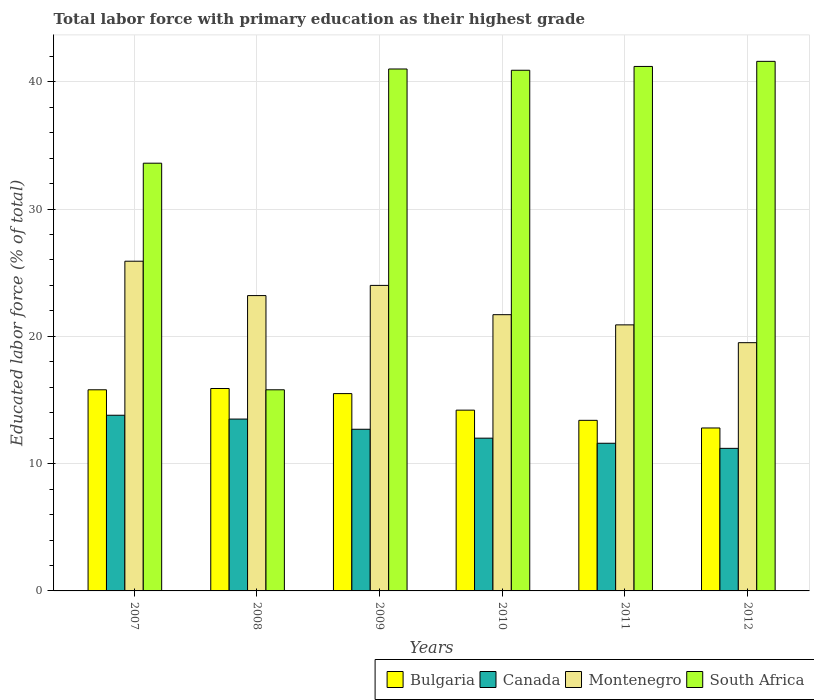How many groups of bars are there?
Give a very brief answer. 6. How many bars are there on the 3rd tick from the left?
Ensure brevity in your answer.  4. What is the label of the 2nd group of bars from the left?
Provide a short and direct response. 2008. What is the percentage of total labor force with primary education in Bulgaria in 2012?
Make the answer very short. 12.8. Across all years, what is the maximum percentage of total labor force with primary education in Montenegro?
Make the answer very short. 25.9. Across all years, what is the minimum percentage of total labor force with primary education in Bulgaria?
Offer a terse response. 12.8. In which year was the percentage of total labor force with primary education in Bulgaria minimum?
Your answer should be compact. 2012. What is the total percentage of total labor force with primary education in Montenegro in the graph?
Give a very brief answer. 135.2. What is the difference between the percentage of total labor force with primary education in Canada in 2008 and that in 2009?
Your answer should be compact. 0.8. What is the difference between the percentage of total labor force with primary education in Montenegro in 2011 and the percentage of total labor force with primary education in Canada in 2007?
Offer a very short reply. 7.1. What is the average percentage of total labor force with primary education in Canada per year?
Ensure brevity in your answer.  12.47. In the year 2007, what is the difference between the percentage of total labor force with primary education in Canada and percentage of total labor force with primary education in South Africa?
Your answer should be compact. -19.8. What is the ratio of the percentage of total labor force with primary education in Montenegro in 2008 to that in 2012?
Your answer should be compact. 1.19. Is the percentage of total labor force with primary education in Montenegro in 2011 less than that in 2012?
Your response must be concise. No. What is the difference between the highest and the second highest percentage of total labor force with primary education in Canada?
Make the answer very short. 0.3. What is the difference between the highest and the lowest percentage of total labor force with primary education in Montenegro?
Provide a short and direct response. 6.4. Is it the case that in every year, the sum of the percentage of total labor force with primary education in Canada and percentage of total labor force with primary education in Montenegro is greater than the sum of percentage of total labor force with primary education in Bulgaria and percentage of total labor force with primary education in South Africa?
Your response must be concise. No. What does the 2nd bar from the right in 2008 represents?
Ensure brevity in your answer.  Montenegro. Is it the case that in every year, the sum of the percentage of total labor force with primary education in Canada and percentage of total labor force with primary education in South Africa is greater than the percentage of total labor force with primary education in Montenegro?
Your response must be concise. Yes. How many bars are there?
Your answer should be compact. 24. How many years are there in the graph?
Your response must be concise. 6. What is the difference between two consecutive major ticks on the Y-axis?
Provide a succinct answer. 10. Are the values on the major ticks of Y-axis written in scientific E-notation?
Offer a terse response. No. Does the graph contain any zero values?
Ensure brevity in your answer.  No. How many legend labels are there?
Your response must be concise. 4. How are the legend labels stacked?
Your answer should be very brief. Horizontal. What is the title of the graph?
Make the answer very short. Total labor force with primary education as their highest grade. Does "Ghana" appear as one of the legend labels in the graph?
Your answer should be very brief. No. What is the label or title of the Y-axis?
Your response must be concise. Educated labor force (% of total). What is the Educated labor force (% of total) in Bulgaria in 2007?
Your answer should be compact. 15.8. What is the Educated labor force (% of total) of Canada in 2007?
Make the answer very short. 13.8. What is the Educated labor force (% of total) in Montenegro in 2007?
Offer a very short reply. 25.9. What is the Educated labor force (% of total) in South Africa in 2007?
Ensure brevity in your answer.  33.6. What is the Educated labor force (% of total) in Bulgaria in 2008?
Provide a short and direct response. 15.9. What is the Educated labor force (% of total) in Canada in 2008?
Keep it short and to the point. 13.5. What is the Educated labor force (% of total) in Montenegro in 2008?
Your response must be concise. 23.2. What is the Educated labor force (% of total) in South Africa in 2008?
Keep it short and to the point. 15.8. What is the Educated labor force (% of total) in Bulgaria in 2009?
Provide a succinct answer. 15.5. What is the Educated labor force (% of total) in Canada in 2009?
Your response must be concise. 12.7. What is the Educated labor force (% of total) of South Africa in 2009?
Your answer should be compact. 41. What is the Educated labor force (% of total) in Bulgaria in 2010?
Your answer should be very brief. 14.2. What is the Educated labor force (% of total) of Canada in 2010?
Your answer should be compact. 12. What is the Educated labor force (% of total) in Montenegro in 2010?
Offer a terse response. 21.7. What is the Educated labor force (% of total) of South Africa in 2010?
Offer a terse response. 40.9. What is the Educated labor force (% of total) of Bulgaria in 2011?
Your answer should be compact. 13.4. What is the Educated labor force (% of total) in Canada in 2011?
Provide a succinct answer. 11.6. What is the Educated labor force (% of total) of Montenegro in 2011?
Your response must be concise. 20.9. What is the Educated labor force (% of total) in South Africa in 2011?
Provide a succinct answer. 41.2. What is the Educated labor force (% of total) of Bulgaria in 2012?
Provide a succinct answer. 12.8. What is the Educated labor force (% of total) of Canada in 2012?
Your answer should be very brief. 11.2. What is the Educated labor force (% of total) of Montenegro in 2012?
Your answer should be compact. 19.5. What is the Educated labor force (% of total) of South Africa in 2012?
Provide a short and direct response. 41.6. Across all years, what is the maximum Educated labor force (% of total) in Bulgaria?
Give a very brief answer. 15.9. Across all years, what is the maximum Educated labor force (% of total) in Canada?
Provide a short and direct response. 13.8. Across all years, what is the maximum Educated labor force (% of total) of Montenegro?
Provide a short and direct response. 25.9. Across all years, what is the maximum Educated labor force (% of total) in South Africa?
Give a very brief answer. 41.6. Across all years, what is the minimum Educated labor force (% of total) in Bulgaria?
Provide a short and direct response. 12.8. Across all years, what is the minimum Educated labor force (% of total) in Canada?
Your response must be concise. 11.2. Across all years, what is the minimum Educated labor force (% of total) of South Africa?
Keep it short and to the point. 15.8. What is the total Educated labor force (% of total) of Bulgaria in the graph?
Ensure brevity in your answer.  87.6. What is the total Educated labor force (% of total) in Canada in the graph?
Make the answer very short. 74.8. What is the total Educated labor force (% of total) of Montenegro in the graph?
Make the answer very short. 135.2. What is the total Educated labor force (% of total) in South Africa in the graph?
Offer a terse response. 214.1. What is the difference between the Educated labor force (% of total) of Bulgaria in 2007 and that in 2008?
Make the answer very short. -0.1. What is the difference between the Educated labor force (% of total) in Canada in 2007 and that in 2008?
Give a very brief answer. 0.3. What is the difference between the Educated labor force (% of total) in South Africa in 2007 and that in 2008?
Provide a short and direct response. 17.8. What is the difference between the Educated labor force (% of total) in Montenegro in 2007 and that in 2009?
Offer a very short reply. 1.9. What is the difference between the Educated labor force (% of total) of South Africa in 2007 and that in 2009?
Your answer should be very brief. -7.4. What is the difference between the Educated labor force (% of total) in Canada in 2007 and that in 2010?
Give a very brief answer. 1.8. What is the difference between the Educated labor force (% of total) in South Africa in 2007 and that in 2010?
Offer a terse response. -7.3. What is the difference between the Educated labor force (% of total) of Montenegro in 2007 and that in 2011?
Give a very brief answer. 5. What is the difference between the Educated labor force (% of total) of South Africa in 2007 and that in 2011?
Keep it short and to the point. -7.6. What is the difference between the Educated labor force (% of total) in Bulgaria in 2007 and that in 2012?
Offer a very short reply. 3. What is the difference between the Educated labor force (% of total) in South Africa in 2007 and that in 2012?
Provide a succinct answer. -8. What is the difference between the Educated labor force (% of total) in South Africa in 2008 and that in 2009?
Offer a very short reply. -25.2. What is the difference between the Educated labor force (% of total) in Bulgaria in 2008 and that in 2010?
Give a very brief answer. 1.7. What is the difference between the Educated labor force (% of total) of South Africa in 2008 and that in 2010?
Your answer should be compact. -25.1. What is the difference between the Educated labor force (% of total) in Bulgaria in 2008 and that in 2011?
Your response must be concise. 2.5. What is the difference between the Educated labor force (% of total) in Canada in 2008 and that in 2011?
Offer a terse response. 1.9. What is the difference between the Educated labor force (% of total) of Montenegro in 2008 and that in 2011?
Your answer should be very brief. 2.3. What is the difference between the Educated labor force (% of total) of South Africa in 2008 and that in 2011?
Provide a succinct answer. -25.4. What is the difference between the Educated labor force (% of total) in Montenegro in 2008 and that in 2012?
Keep it short and to the point. 3.7. What is the difference between the Educated labor force (% of total) of South Africa in 2008 and that in 2012?
Make the answer very short. -25.8. What is the difference between the Educated labor force (% of total) of Bulgaria in 2009 and that in 2010?
Offer a terse response. 1.3. What is the difference between the Educated labor force (% of total) of South Africa in 2009 and that in 2011?
Your answer should be compact. -0.2. What is the difference between the Educated labor force (% of total) of Bulgaria in 2009 and that in 2012?
Make the answer very short. 2.7. What is the difference between the Educated labor force (% of total) in Canada in 2009 and that in 2012?
Make the answer very short. 1.5. What is the difference between the Educated labor force (% of total) of South Africa in 2009 and that in 2012?
Your answer should be very brief. -0.6. What is the difference between the Educated labor force (% of total) in Canada in 2010 and that in 2011?
Offer a terse response. 0.4. What is the difference between the Educated labor force (% of total) in Montenegro in 2010 and that in 2011?
Your answer should be compact. 0.8. What is the difference between the Educated labor force (% of total) of South Africa in 2010 and that in 2011?
Your answer should be very brief. -0.3. What is the difference between the Educated labor force (% of total) of Bulgaria in 2010 and that in 2012?
Provide a short and direct response. 1.4. What is the difference between the Educated labor force (% of total) in South Africa in 2010 and that in 2012?
Keep it short and to the point. -0.7. What is the difference between the Educated labor force (% of total) of Montenegro in 2011 and that in 2012?
Your response must be concise. 1.4. What is the difference between the Educated labor force (% of total) in Bulgaria in 2007 and the Educated labor force (% of total) in South Africa in 2008?
Give a very brief answer. 0. What is the difference between the Educated labor force (% of total) in Canada in 2007 and the Educated labor force (% of total) in Montenegro in 2008?
Provide a succinct answer. -9.4. What is the difference between the Educated labor force (% of total) in Canada in 2007 and the Educated labor force (% of total) in South Africa in 2008?
Offer a terse response. -2. What is the difference between the Educated labor force (% of total) of Bulgaria in 2007 and the Educated labor force (% of total) of Canada in 2009?
Offer a terse response. 3.1. What is the difference between the Educated labor force (% of total) of Bulgaria in 2007 and the Educated labor force (% of total) of South Africa in 2009?
Provide a succinct answer. -25.2. What is the difference between the Educated labor force (% of total) of Canada in 2007 and the Educated labor force (% of total) of South Africa in 2009?
Your answer should be compact. -27.2. What is the difference between the Educated labor force (% of total) in Montenegro in 2007 and the Educated labor force (% of total) in South Africa in 2009?
Your response must be concise. -15.1. What is the difference between the Educated labor force (% of total) of Bulgaria in 2007 and the Educated labor force (% of total) of Canada in 2010?
Ensure brevity in your answer.  3.8. What is the difference between the Educated labor force (% of total) of Bulgaria in 2007 and the Educated labor force (% of total) of South Africa in 2010?
Provide a short and direct response. -25.1. What is the difference between the Educated labor force (% of total) in Canada in 2007 and the Educated labor force (% of total) in Montenegro in 2010?
Make the answer very short. -7.9. What is the difference between the Educated labor force (% of total) of Canada in 2007 and the Educated labor force (% of total) of South Africa in 2010?
Offer a terse response. -27.1. What is the difference between the Educated labor force (% of total) in Montenegro in 2007 and the Educated labor force (% of total) in South Africa in 2010?
Ensure brevity in your answer.  -15. What is the difference between the Educated labor force (% of total) in Bulgaria in 2007 and the Educated labor force (% of total) in Canada in 2011?
Offer a terse response. 4.2. What is the difference between the Educated labor force (% of total) in Bulgaria in 2007 and the Educated labor force (% of total) in South Africa in 2011?
Your response must be concise. -25.4. What is the difference between the Educated labor force (% of total) in Canada in 2007 and the Educated labor force (% of total) in Montenegro in 2011?
Offer a terse response. -7.1. What is the difference between the Educated labor force (% of total) in Canada in 2007 and the Educated labor force (% of total) in South Africa in 2011?
Provide a short and direct response. -27.4. What is the difference between the Educated labor force (% of total) in Montenegro in 2007 and the Educated labor force (% of total) in South Africa in 2011?
Make the answer very short. -15.3. What is the difference between the Educated labor force (% of total) in Bulgaria in 2007 and the Educated labor force (% of total) in Montenegro in 2012?
Your answer should be compact. -3.7. What is the difference between the Educated labor force (% of total) in Bulgaria in 2007 and the Educated labor force (% of total) in South Africa in 2012?
Make the answer very short. -25.8. What is the difference between the Educated labor force (% of total) of Canada in 2007 and the Educated labor force (% of total) of South Africa in 2012?
Your answer should be compact. -27.8. What is the difference between the Educated labor force (% of total) of Montenegro in 2007 and the Educated labor force (% of total) of South Africa in 2012?
Give a very brief answer. -15.7. What is the difference between the Educated labor force (% of total) in Bulgaria in 2008 and the Educated labor force (% of total) in Canada in 2009?
Give a very brief answer. 3.2. What is the difference between the Educated labor force (% of total) in Bulgaria in 2008 and the Educated labor force (% of total) in South Africa in 2009?
Your response must be concise. -25.1. What is the difference between the Educated labor force (% of total) of Canada in 2008 and the Educated labor force (% of total) of South Africa in 2009?
Provide a succinct answer. -27.5. What is the difference between the Educated labor force (% of total) in Montenegro in 2008 and the Educated labor force (% of total) in South Africa in 2009?
Offer a very short reply. -17.8. What is the difference between the Educated labor force (% of total) of Bulgaria in 2008 and the Educated labor force (% of total) of South Africa in 2010?
Keep it short and to the point. -25. What is the difference between the Educated labor force (% of total) in Canada in 2008 and the Educated labor force (% of total) in Montenegro in 2010?
Your answer should be very brief. -8.2. What is the difference between the Educated labor force (% of total) of Canada in 2008 and the Educated labor force (% of total) of South Africa in 2010?
Your answer should be compact. -27.4. What is the difference between the Educated labor force (% of total) of Montenegro in 2008 and the Educated labor force (% of total) of South Africa in 2010?
Provide a short and direct response. -17.7. What is the difference between the Educated labor force (% of total) in Bulgaria in 2008 and the Educated labor force (% of total) in Canada in 2011?
Your response must be concise. 4.3. What is the difference between the Educated labor force (% of total) of Bulgaria in 2008 and the Educated labor force (% of total) of Montenegro in 2011?
Your answer should be very brief. -5. What is the difference between the Educated labor force (% of total) of Bulgaria in 2008 and the Educated labor force (% of total) of South Africa in 2011?
Keep it short and to the point. -25.3. What is the difference between the Educated labor force (% of total) of Canada in 2008 and the Educated labor force (% of total) of South Africa in 2011?
Give a very brief answer. -27.7. What is the difference between the Educated labor force (% of total) of Montenegro in 2008 and the Educated labor force (% of total) of South Africa in 2011?
Make the answer very short. -18. What is the difference between the Educated labor force (% of total) in Bulgaria in 2008 and the Educated labor force (% of total) in South Africa in 2012?
Ensure brevity in your answer.  -25.7. What is the difference between the Educated labor force (% of total) of Canada in 2008 and the Educated labor force (% of total) of Montenegro in 2012?
Your response must be concise. -6. What is the difference between the Educated labor force (% of total) in Canada in 2008 and the Educated labor force (% of total) in South Africa in 2012?
Offer a very short reply. -28.1. What is the difference between the Educated labor force (% of total) in Montenegro in 2008 and the Educated labor force (% of total) in South Africa in 2012?
Your answer should be compact. -18.4. What is the difference between the Educated labor force (% of total) in Bulgaria in 2009 and the Educated labor force (% of total) in Canada in 2010?
Ensure brevity in your answer.  3.5. What is the difference between the Educated labor force (% of total) in Bulgaria in 2009 and the Educated labor force (% of total) in Montenegro in 2010?
Ensure brevity in your answer.  -6.2. What is the difference between the Educated labor force (% of total) in Bulgaria in 2009 and the Educated labor force (% of total) in South Africa in 2010?
Provide a short and direct response. -25.4. What is the difference between the Educated labor force (% of total) of Canada in 2009 and the Educated labor force (% of total) of South Africa in 2010?
Your answer should be very brief. -28.2. What is the difference between the Educated labor force (% of total) of Montenegro in 2009 and the Educated labor force (% of total) of South Africa in 2010?
Your response must be concise. -16.9. What is the difference between the Educated labor force (% of total) of Bulgaria in 2009 and the Educated labor force (% of total) of Montenegro in 2011?
Give a very brief answer. -5.4. What is the difference between the Educated labor force (% of total) in Bulgaria in 2009 and the Educated labor force (% of total) in South Africa in 2011?
Keep it short and to the point. -25.7. What is the difference between the Educated labor force (% of total) of Canada in 2009 and the Educated labor force (% of total) of Montenegro in 2011?
Provide a short and direct response. -8.2. What is the difference between the Educated labor force (% of total) of Canada in 2009 and the Educated labor force (% of total) of South Africa in 2011?
Give a very brief answer. -28.5. What is the difference between the Educated labor force (% of total) of Montenegro in 2009 and the Educated labor force (% of total) of South Africa in 2011?
Your answer should be very brief. -17.2. What is the difference between the Educated labor force (% of total) of Bulgaria in 2009 and the Educated labor force (% of total) of Canada in 2012?
Offer a terse response. 4.3. What is the difference between the Educated labor force (% of total) in Bulgaria in 2009 and the Educated labor force (% of total) in Montenegro in 2012?
Offer a very short reply. -4. What is the difference between the Educated labor force (% of total) in Bulgaria in 2009 and the Educated labor force (% of total) in South Africa in 2012?
Give a very brief answer. -26.1. What is the difference between the Educated labor force (% of total) of Canada in 2009 and the Educated labor force (% of total) of Montenegro in 2012?
Offer a terse response. -6.8. What is the difference between the Educated labor force (% of total) in Canada in 2009 and the Educated labor force (% of total) in South Africa in 2012?
Provide a short and direct response. -28.9. What is the difference between the Educated labor force (% of total) of Montenegro in 2009 and the Educated labor force (% of total) of South Africa in 2012?
Your answer should be very brief. -17.6. What is the difference between the Educated labor force (% of total) of Bulgaria in 2010 and the Educated labor force (% of total) of South Africa in 2011?
Your answer should be very brief. -27. What is the difference between the Educated labor force (% of total) of Canada in 2010 and the Educated labor force (% of total) of South Africa in 2011?
Your response must be concise. -29.2. What is the difference between the Educated labor force (% of total) of Montenegro in 2010 and the Educated labor force (% of total) of South Africa in 2011?
Give a very brief answer. -19.5. What is the difference between the Educated labor force (% of total) of Bulgaria in 2010 and the Educated labor force (% of total) of Canada in 2012?
Make the answer very short. 3. What is the difference between the Educated labor force (% of total) of Bulgaria in 2010 and the Educated labor force (% of total) of Montenegro in 2012?
Your answer should be compact. -5.3. What is the difference between the Educated labor force (% of total) of Bulgaria in 2010 and the Educated labor force (% of total) of South Africa in 2012?
Give a very brief answer. -27.4. What is the difference between the Educated labor force (% of total) in Canada in 2010 and the Educated labor force (% of total) in South Africa in 2012?
Give a very brief answer. -29.6. What is the difference between the Educated labor force (% of total) of Montenegro in 2010 and the Educated labor force (% of total) of South Africa in 2012?
Keep it short and to the point. -19.9. What is the difference between the Educated labor force (% of total) in Bulgaria in 2011 and the Educated labor force (% of total) in South Africa in 2012?
Your answer should be very brief. -28.2. What is the difference between the Educated labor force (% of total) in Montenegro in 2011 and the Educated labor force (% of total) in South Africa in 2012?
Ensure brevity in your answer.  -20.7. What is the average Educated labor force (% of total) of Bulgaria per year?
Give a very brief answer. 14.6. What is the average Educated labor force (% of total) of Canada per year?
Make the answer very short. 12.47. What is the average Educated labor force (% of total) in Montenegro per year?
Keep it short and to the point. 22.53. What is the average Educated labor force (% of total) in South Africa per year?
Offer a very short reply. 35.68. In the year 2007, what is the difference between the Educated labor force (% of total) in Bulgaria and Educated labor force (% of total) in Montenegro?
Ensure brevity in your answer.  -10.1. In the year 2007, what is the difference between the Educated labor force (% of total) of Bulgaria and Educated labor force (% of total) of South Africa?
Your answer should be very brief. -17.8. In the year 2007, what is the difference between the Educated labor force (% of total) of Canada and Educated labor force (% of total) of Montenegro?
Provide a short and direct response. -12.1. In the year 2007, what is the difference between the Educated labor force (% of total) in Canada and Educated labor force (% of total) in South Africa?
Provide a short and direct response. -19.8. In the year 2007, what is the difference between the Educated labor force (% of total) of Montenegro and Educated labor force (% of total) of South Africa?
Offer a very short reply. -7.7. In the year 2008, what is the difference between the Educated labor force (% of total) of Canada and Educated labor force (% of total) of Montenegro?
Offer a terse response. -9.7. In the year 2008, what is the difference between the Educated labor force (% of total) in Canada and Educated labor force (% of total) in South Africa?
Give a very brief answer. -2.3. In the year 2008, what is the difference between the Educated labor force (% of total) of Montenegro and Educated labor force (% of total) of South Africa?
Ensure brevity in your answer.  7.4. In the year 2009, what is the difference between the Educated labor force (% of total) of Bulgaria and Educated labor force (% of total) of Canada?
Offer a very short reply. 2.8. In the year 2009, what is the difference between the Educated labor force (% of total) of Bulgaria and Educated labor force (% of total) of South Africa?
Offer a terse response. -25.5. In the year 2009, what is the difference between the Educated labor force (% of total) in Canada and Educated labor force (% of total) in Montenegro?
Make the answer very short. -11.3. In the year 2009, what is the difference between the Educated labor force (% of total) in Canada and Educated labor force (% of total) in South Africa?
Offer a terse response. -28.3. In the year 2010, what is the difference between the Educated labor force (% of total) in Bulgaria and Educated labor force (% of total) in Canada?
Your answer should be very brief. 2.2. In the year 2010, what is the difference between the Educated labor force (% of total) of Bulgaria and Educated labor force (% of total) of South Africa?
Make the answer very short. -26.7. In the year 2010, what is the difference between the Educated labor force (% of total) of Canada and Educated labor force (% of total) of South Africa?
Provide a succinct answer. -28.9. In the year 2010, what is the difference between the Educated labor force (% of total) of Montenegro and Educated labor force (% of total) of South Africa?
Offer a terse response. -19.2. In the year 2011, what is the difference between the Educated labor force (% of total) of Bulgaria and Educated labor force (% of total) of South Africa?
Provide a succinct answer. -27.8. In the year 2011, what is the difference between the Educated labor force (% of total) in Canada and Educated labor force (% of total) in South Africa?
Give a very brief answer. -29.6. In the year 2011, what is the difference between the Educated labor force (% of total) of Montenegro and Educated labor force (% of total) of South Africa?
Ensure brevity in your answer.  -20.3. In the year 2012, what is the difference between the Educated labor force (% of total) in Bulgaria and Educated labor force (% of total) in Montenegro?
Keep it short and to the point. -6.7. In the year 2012, what is the difference between the Educated labor force (% of total) in Bulgaria and Educated labor force (% of total) in South Africa?
Provide a short and direct response. -28.8. In the year 2012, what is the difference between the Educated labor force (% of total) in Canada and Educated labor force (% of total) in South Africa?
Make the answer very short. -30.4. In the year 2012, what is the difference between the Educated labor force (% of total) of Montenegro and Educated labor force (% of total) of South Africa?
Your response must be concise. -22.1. What is the ratio of the Educated labor force (% of total) of Canada in 2007 to that in 2008?
Your answer should be very brief. 1.02. What is the ratio of the Educated labor force (% of total) of Montenegro in 2007 to that in 2008?
Your answer should be very brief. 1.12. What is the ratio of the Educated labor force (% of total) of South Africa in 2007 to that in 2008?
Your response must be concise. 2.13. What is the ratio of the Educated labor force (% of total) of Bulgaria in 2007 to that in 2009?
Offer a very short reply. 1.02. What is the ratio of the Educated labor force (% of total) of Canada in 2007 to that in 2009?
Offer a terse response. 1.09. What is the ratio of the Educated labor force (% of total) of Montenegro in 2007 to that in 2009?
Keep it short and to the point. 1.08. What is the ratio of the Educated labor force (% of total) of South Africa in 2007 to that in 2009?
Offer a terse response. 0.82. What is the ratio of the Educated labor force (% of total) of Bulgaria in 2007 to that in 2010?
Provide a short and direct response. 1.11. What is the ratio of the Educated labor force (% of total) of Canada in 2007 to that in 2010?
Your response must be concise. 1.15. What is the ratio of the Educated labor force (% of total) in Montenegro in 2007 to that in 2010?
Ensure brevity in your answer.  1.19. What is the ratio of the Educated labor force (% of total) in South Africa in 2007 to that in 2010?
Provide a succinct answer. 0.82. What is the ratio of the Educated labor force (% of total) of Bulgaria in 2007 to that in 2011?
Your response must be concise. 1.18. What is the ratio of the Educated labor force (% of total) of Canada in 2007 to that in 2011?
Offer a terse response. 1.19. What is the ratio of the Educated labor force (% of total) of Montenegro in 2007 to that in 2011?
Provide a short and direct response. 1.24. What is the ratio of the Educated labor force (% of total) of South Africa in 2007 to that in 2011?
Give a very brief answer. 0.82. What is the ratio of the Educated labor force (% of total) in Bulgaria in 2007 to that in 2012?
Your answer should be compact. 1.23. What is the ratio of the Educated labor force (% of total) of Canada in 2007 to that in 2012?
Your response must be concise. 1.23. What is the ratio of the Educated labor force (% of total) in Montenegro in 2007 to that in 2012?
Ensure brevity in your answer.  1.33. What is the ratio of the Educated labor force (% of total) in South Africa in 2007 to that in 2012?
Provide a succinct answer. 0.81. What is the ratio of the Educated labor force (% of total) of Bulgaria in 2008 to that in 2009?
Offer a terse response. 1.03. What is the ratio of the Educated labor force (% of total) in Canada in 2008 to that in 2009?
Your response must be concise. 1.06. What is the ratio of the Educated labor force (% of total) in Montenegro in 2008 to that in 2009?
Keep it short and to the point. 0.97. What is the ratio of the Educated labor force (% of total) of South Africa in 2008 to that in 2009?
Provide a short and direct response. 0.39. What is the ratio of the Educated labor force (% of total) of Bulgaria in 2008 to that in 2010?
Your answer should be compact. 1.12. What is the ratio of the Educated labor force (% of total) of Canada in 2008 to that in 2010?
Ensure brevity in your answer.  1.12. What is the ratio of the Educated labor force (% of total) in Montenegro in 2008 to that in 2010?
Your answer should be compact. 1.07. What is the ratio of the Educated labor force (% of total) of South Africa in 2008 to that in 2010?
Give a very brief answer. 0.39. What is the ratio of the Educated labor force (% of total) of Bulgaria in 2008 to that in 2011?
Offer a terse response. 1.19. What is the ratio of the Educated labor force (% of total) in Canada in 2008 to that in 2011?
Ensure brevity in your answer.  1.16. What is the ratio of the Educated labor force (% of total) in Montenegro in 2008 to that in 2011?
Your response must be concise. 1.11. What is the ratio of the Educated labor force (% of total) in South Africa in 2008 to that in 2011?
Provide a succinct answer. 0.38. What is the ratio of the Educated labor force (% of total) of Bulgaria in 2008 to that in 2012?
Offer a terse response. 1.24. What is the ratio of the Educated labor force (% of total) of Canada in 2008 to that in 2012?
Provide a short and direct response. 1.21. What is the ratio of the Educated labor force (% of total) of Montenegro in 2008 to that in 2012?
Make the answer very short. 1.19. What is the ratio of the Educated labor force (% of total) of South Africa in 2008 to that in 2012?
Keep it short and to the point. 0.38. What is the ratio of the Educated labor force (% of total) of Bulgaria in 2009 to that in 2010?
Ensure brevity in your answer.  1.09. What is the ratio of the Educated labor force (% of total) in Canada in 2009 to that in 2010?
Provide a succinct answer. 1.06. What is the ratio of the Educated labor force (% of total) of Montenegro in 2009 to that in 2010?
Your answer should be compact. 1.11. What is the ratio of the Educated labor force (% of total) of South Africa in 2009 to that in 2010?
Your response must be concise. 1. What is the ratio of the Educated labor force (% of total) in Bulgaria in 2009 to that in 2011?
Give a very brief answer. 1.16. What is the ratio of the Educated labor force (% of total) of Canada in 2009 to that in 2011?
Offer a terse response. 1.09. What is the ratio of the Educated labor force (% of total) in Montenegro in 2009 to that in 2011?
Provide a short and direct response. 1.15. What is the ratio of the Educated labor force (% of total) of South Africa in 2009 to that in 2011?
Make the answer very short. 1. What is the ratio of the Educated labor force (% of total) in Bulgaria in 2009 to that in 2012?
Keep it short and to the point. 1.21. What is the ratio of the Educated labor force (% of total) of Canada in 2009 to that in 2012?
Make the answer very short. 1.13. What is the ratio of the Educated labor force (% of total) in Montenegro in 2009 to that in 2012?
Offer a terse response. 1.23. What is the ratio of the Educated labor force (% of total) in South Africa in 2009 to that in 2012?
Your answer should be compact. 0.99. What is the ratio of the Educated labor force (% of total) of Bulgaria in 2010 to that in 2011?
Give a very brief answer. 1.06. What is the ratio of the Educated labor force (% of total) of Canada in 2010 to that in 2011?
Give a very brief answer. 1.03. What is the ratio of the Educated labor force (% of total) of Montenegro in 2010 to that in 2011?
Provide a succinct answer. 1.04. What is the ratio of the Educated labor force (% of total) of South Africa in 2010 to that in 2011?
Offer a very short reply. 0.99. What is the ratio of the Educated labor force (% of total) of Bulgaria in 2010 to that in 2012?
Your answer should be very brief. 1.11. What is the ratio of the Educated labor force (% of total) in Canada in 2010 to that in 2012?
Offer a very short reply. 1.07. What is the ratio of the Educated labor force (% of total) of Montenegro in 2010 to that in 2012?
Your answer should be compact. 1.11. What is the ratio of the Educated labor force (% of total) of South Africa in 2010 to that in 2012?
Your answer should be compact. 0.98. What is the ratio of the Educated labor force (% of total) in Bulgaria in 2011 to that in 2012?
Keep it short and to the point. 1.05. What is the ratio of the Educated labor force (% of total) in Canada in 2011 to that in 2012?
Keep it short and to the point. 1.04. What is the ratio of the Educated labor force (% of total) of Montenegro in 2011 to that in 2012?
Provide a succinct answer. 1.07. What is the ratio of the Educated labor force (% of total) of South Africa in 2011 to that in 2012?
Provide a short and direct response. 0.99. What is the difference between the highest and the second highest Educated labor force (% of total) of Bulgaria?
Provide a short and direct response. 0.1. What is the difference between the highest and the second highest Educated labor force (% of total) of Canada?
Give a very brief answer. 0.3. What is the difference between the highest and the second highest Educated labor force (% of total) in Montenegro?
Ensure brevity in your answer.  1.9. What is the difference between the highest and the second highest Educated labor force (% of total) in South Africa?
Offer a very short reply. 0.4. What is the difference between the highest and the lowest Educated labor force (% of total) in Canada?
Make the answer very short. 2.6. What is the difference between the highest and the lowest Educated labor force (% of total) of Montenegro?
Ensure brevity in your answer.  6.4. What is the difference between the highest and the lowest Educated labor force (% of total) in South Africa?
Give a very brief answer. 25.8. 